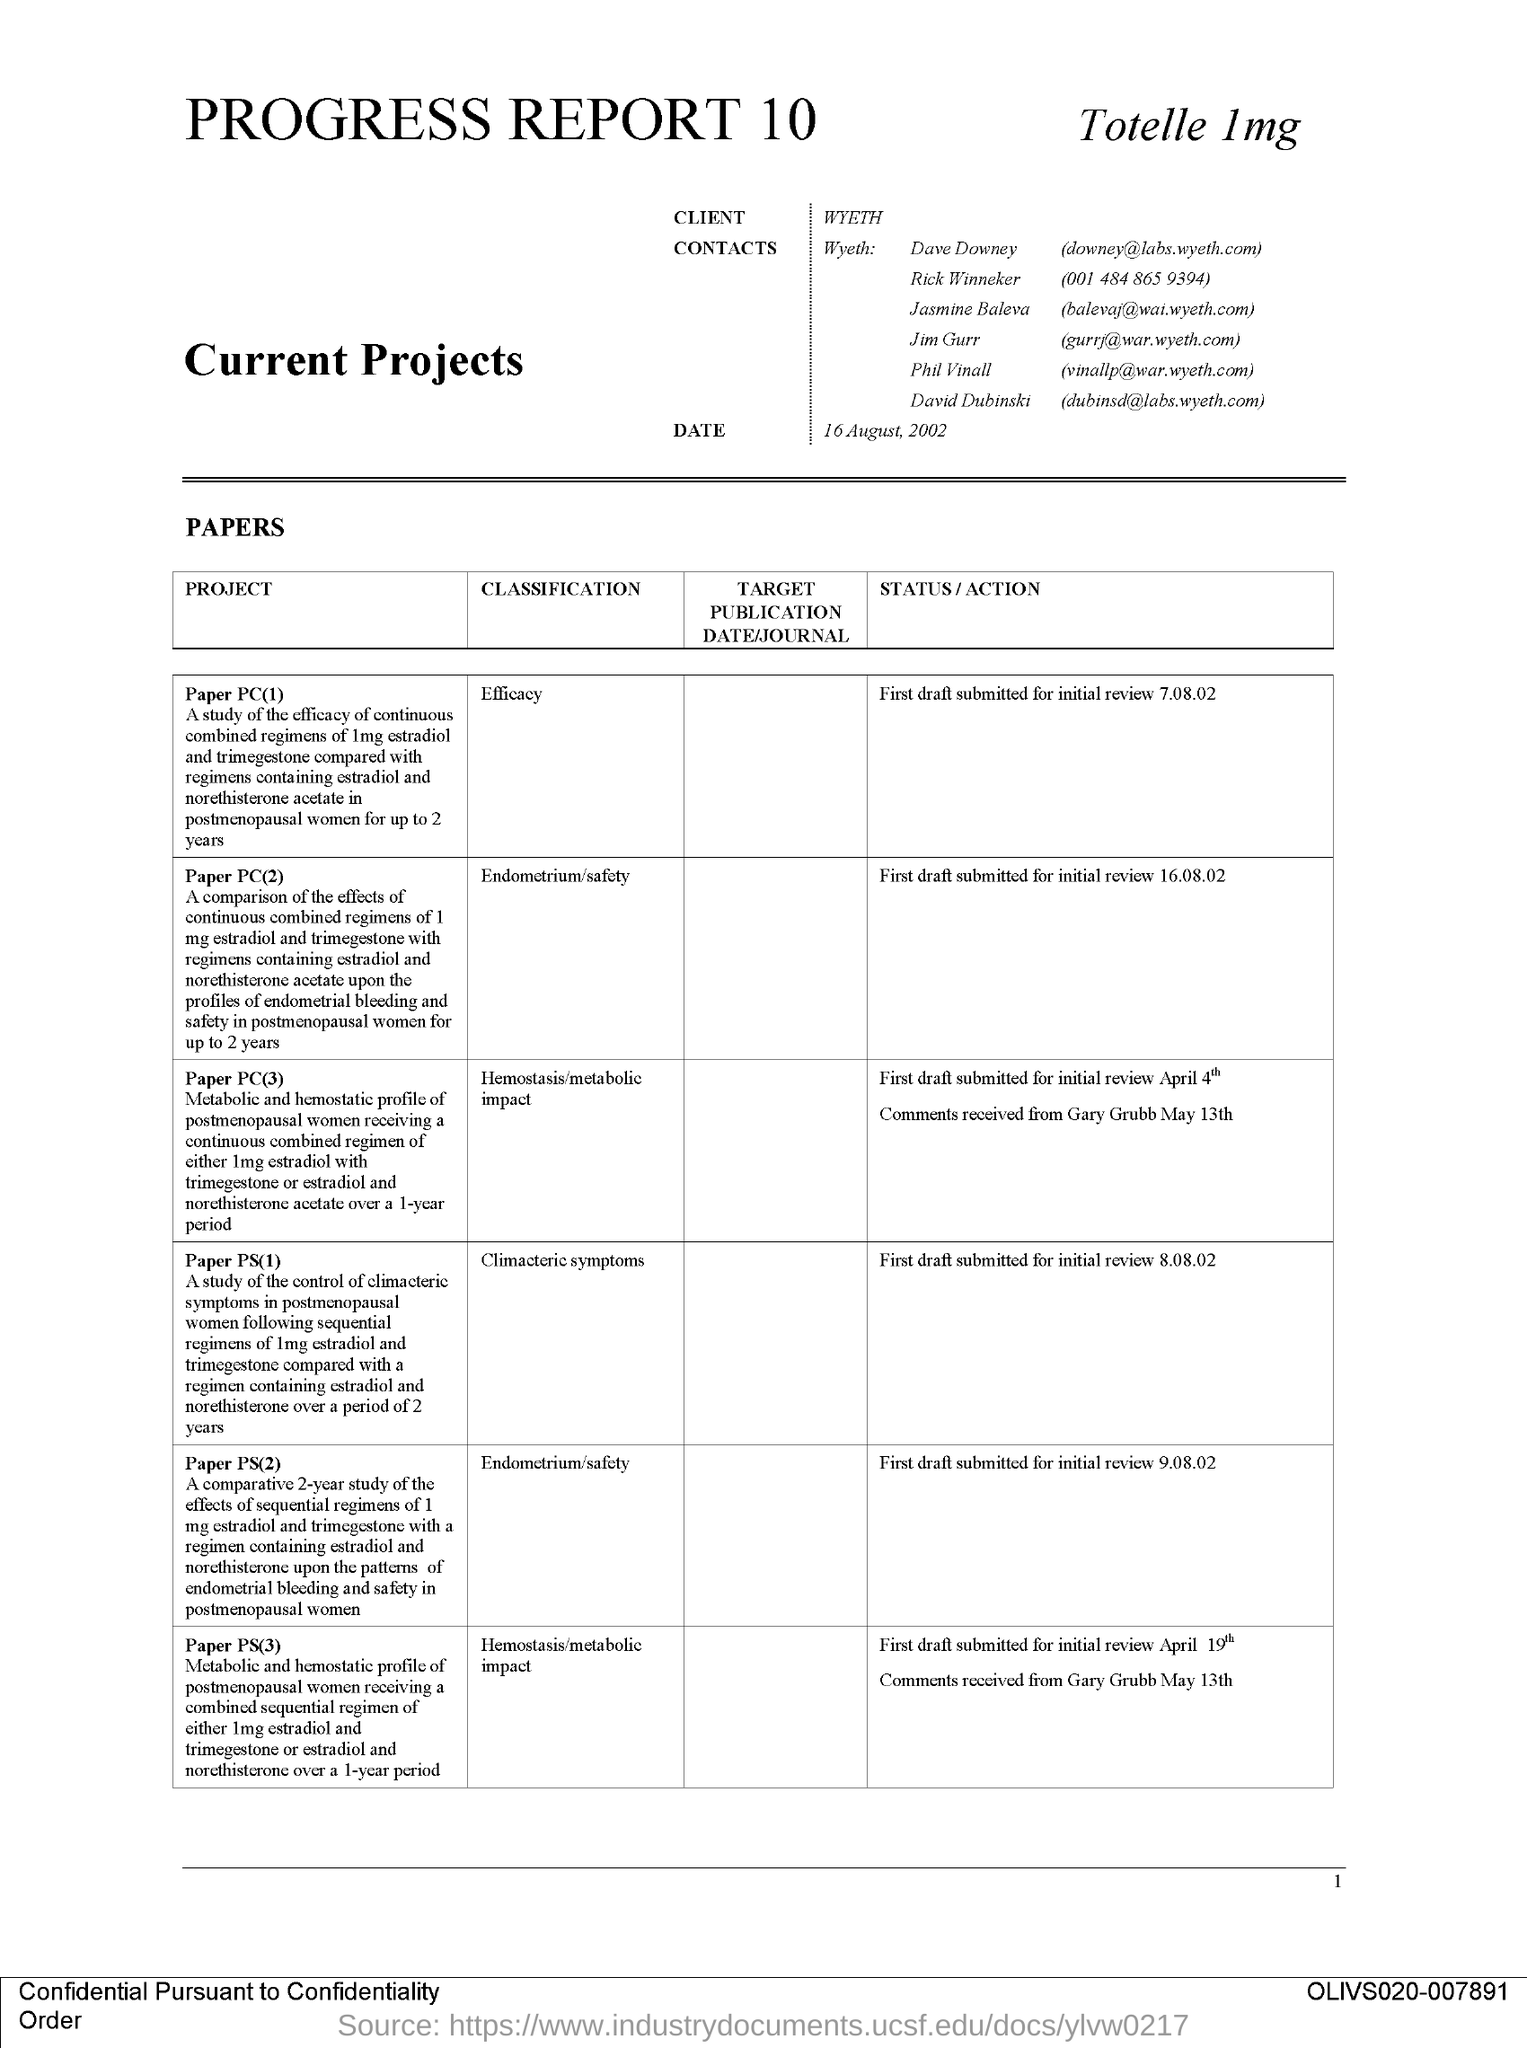What is the heading of the REPORT?
Offer a very short reply. Progress report 10. Mention the "DATE" given at the top of the table?
Keep it short and to the point. 16 August, 2002. Mention the "CLIENT" name given?
Ensure brevity in your answer.  Wyeth. What is the first "Paper" given under the "PROJECT" column?
Provide a succinct answer. Paper PC(1). What is mentioned under "CLASSIFICATION" for Paper PC(2)?
Provide a succinct answer. Endometrium/safety. What is the code number mentioned on the right bottom of the page?
Provide a succinct answer. OLIVS020-007891. What is mentioned under "CLASSIFICATION" for Paper PS(1)?
Offer a terse response. Climacteric symptoms. What is mentioned under "CLASSIFICATION" for Paper PS(3)?
Offer a terse response. Hemostasis/metabolic impact. What is the telephone number of "Rick Winneker"?
Keep it short and to the point. (001 484 865 9394). 